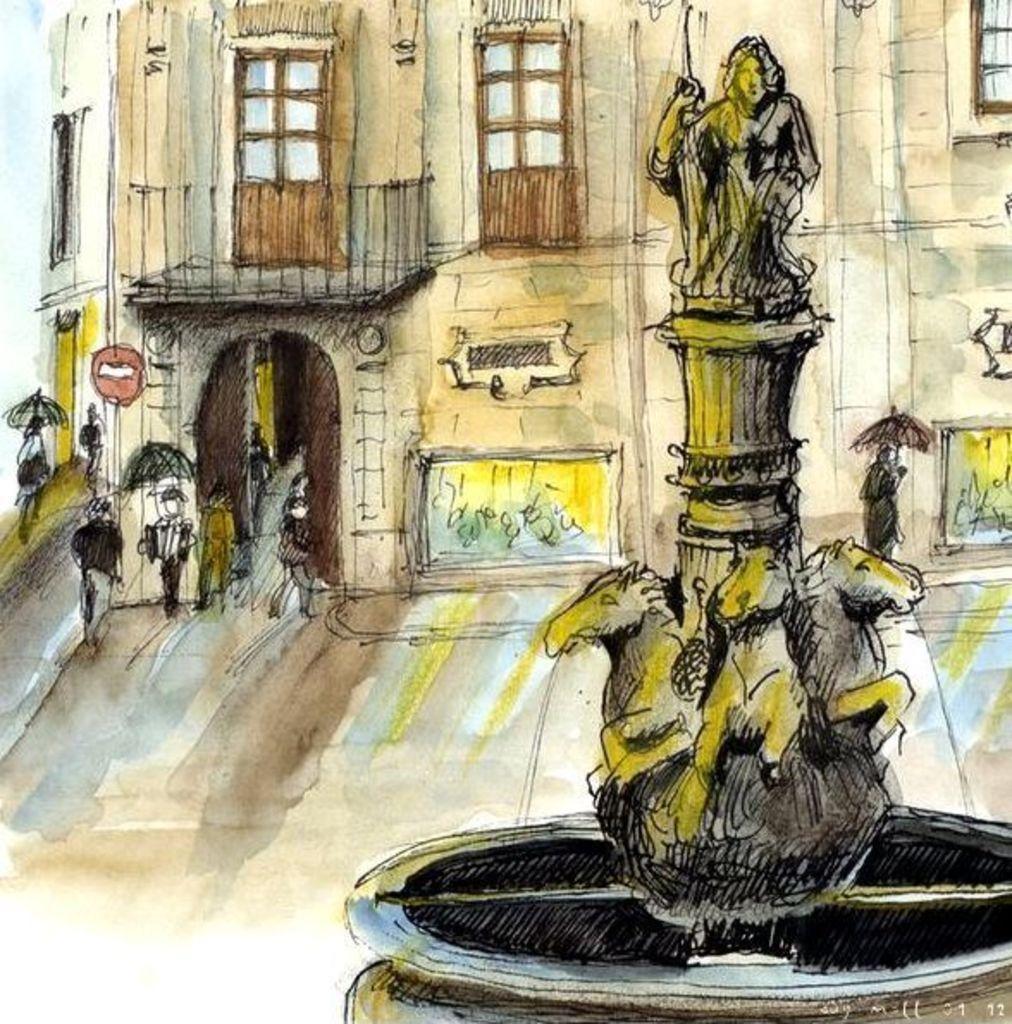Describe this image in one or two sentences. In this image I can see depiction picture where I can see few people, few sculptures and few buildings. 